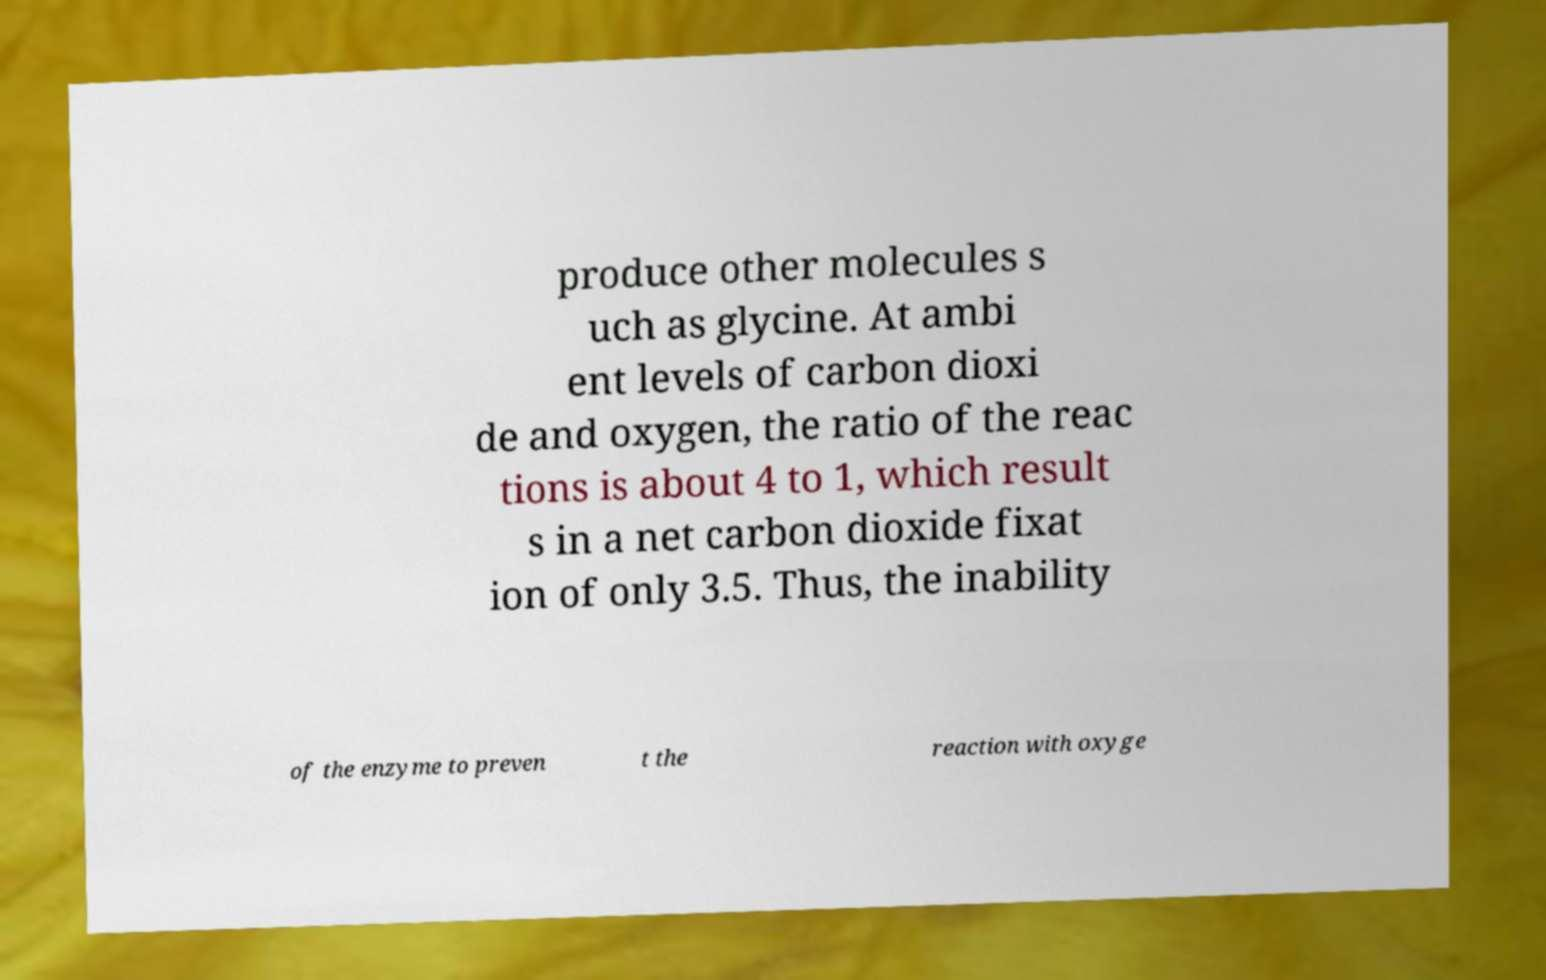What messages or text are displayed in this image? I need them in a readable, typed format. produce other molecules s uch as glycine. At ambi ent levels of carbon dioxi de and oxygen, the ratio of the reac tions is about 4 to 1, which result s in a net carbon dioxide fixat ion of only 3.5. Thus, the inability of the enzyme to preven t the reaction with oxyge 